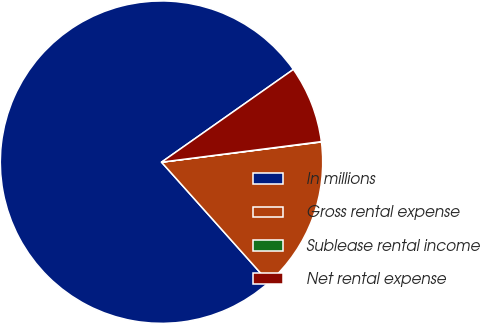<chart> <loc_0><loc_0><loc_500><loc_500><pie_chart><fcel>In millions<fcel>Gross rental expense<fcel>Sublease rental income<fcel>Net rental expense<nl><fcel>76.85%<fcel>15.4%<fcel>0.03%<fcel>7.72%<nl></chart> 